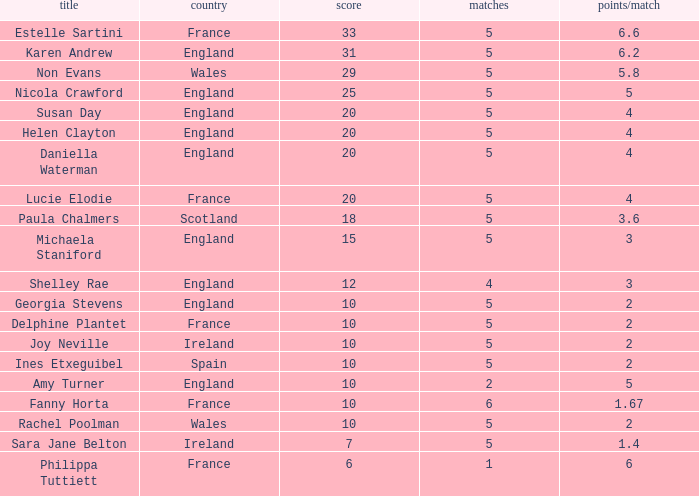Can you tell me the average Points that has a Pts/game larger than 4, and the Nation of england, and the Games smaller than 5? 10.0. 